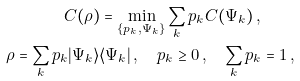Convert formula to latex. <formula><loc_0><loc_0><loc_500><loc_500>C ( \rho ) = \min _ { \{ p _ { k } , \Psi _ { k } \} } \sum _ { k } p _ { k } C ( \Psi _ { k } ) \, , \quad \\ \rho = \sum _ { k } p _ { k } | \Psi _ { k } \rangle \langle \Psi _ { k } | \, , \quad p _ { k } \geq 0 \, , \quad \sum _ { k } p _ { k } = 1 \, ,</formula> 